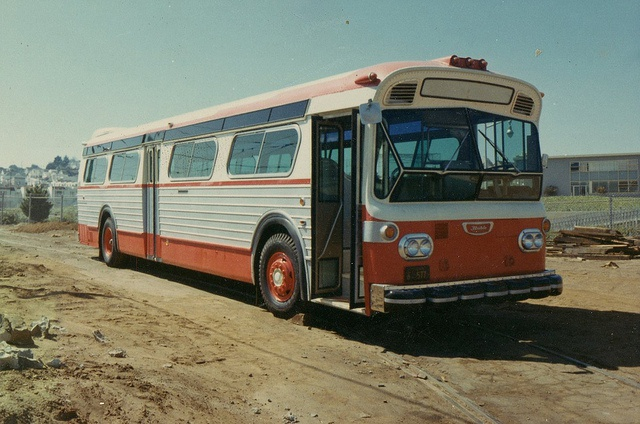Describe the objects in this image and their specific colors. I can see bus in darkgray, black, gray, and maroon tones in this image. 